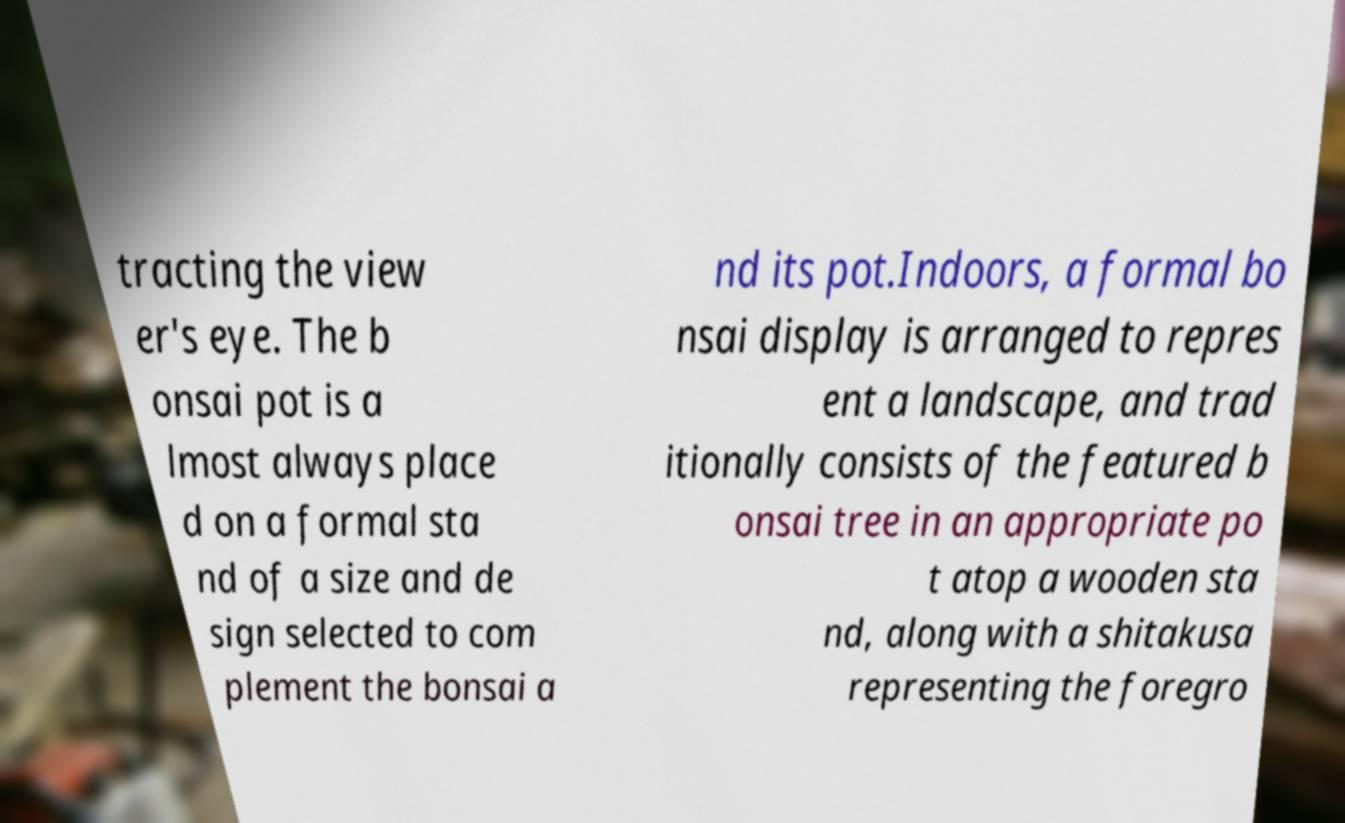Can you read and provide the text displayed in the image?This photo seems to have some interesting text. Can you extract and type it out for me? tracting the view er's eye. The b onsai pot is a lmost always place d on a formal sta nd of a size and de sign selected to com plement the bonsai a nd its pot.Indoors, a formal bo nsai display is arranged to repres ent a landscape, and trad itionally consists of the featured b onsai tree in an appropriate po t atop a wooden sta nd, along with a shitakusa representing the foregro 